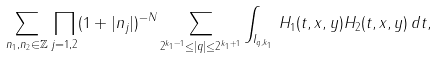Convert formula to latex. <formula><loc_0><loc_0><loc_500><loc_500>\sum _ { n _ { 1 } , n _ { 2 } \in \mathbb { Z } } \prod _ { j = 1 , 2 } ( 1 + | n _ { j } | ) ^ { - N } \sum _ { 2 ^ { k _ { 1 } - 1 } \leq | q | \leq 2 ^ { k _ { 1 } + 1 } } \int _ { I _ { q , k _ { 1 } } } \, H _ { 1 } ( t , x , y ) H _ { 2 } ( t , x , y ) \, d t ,</formula> 